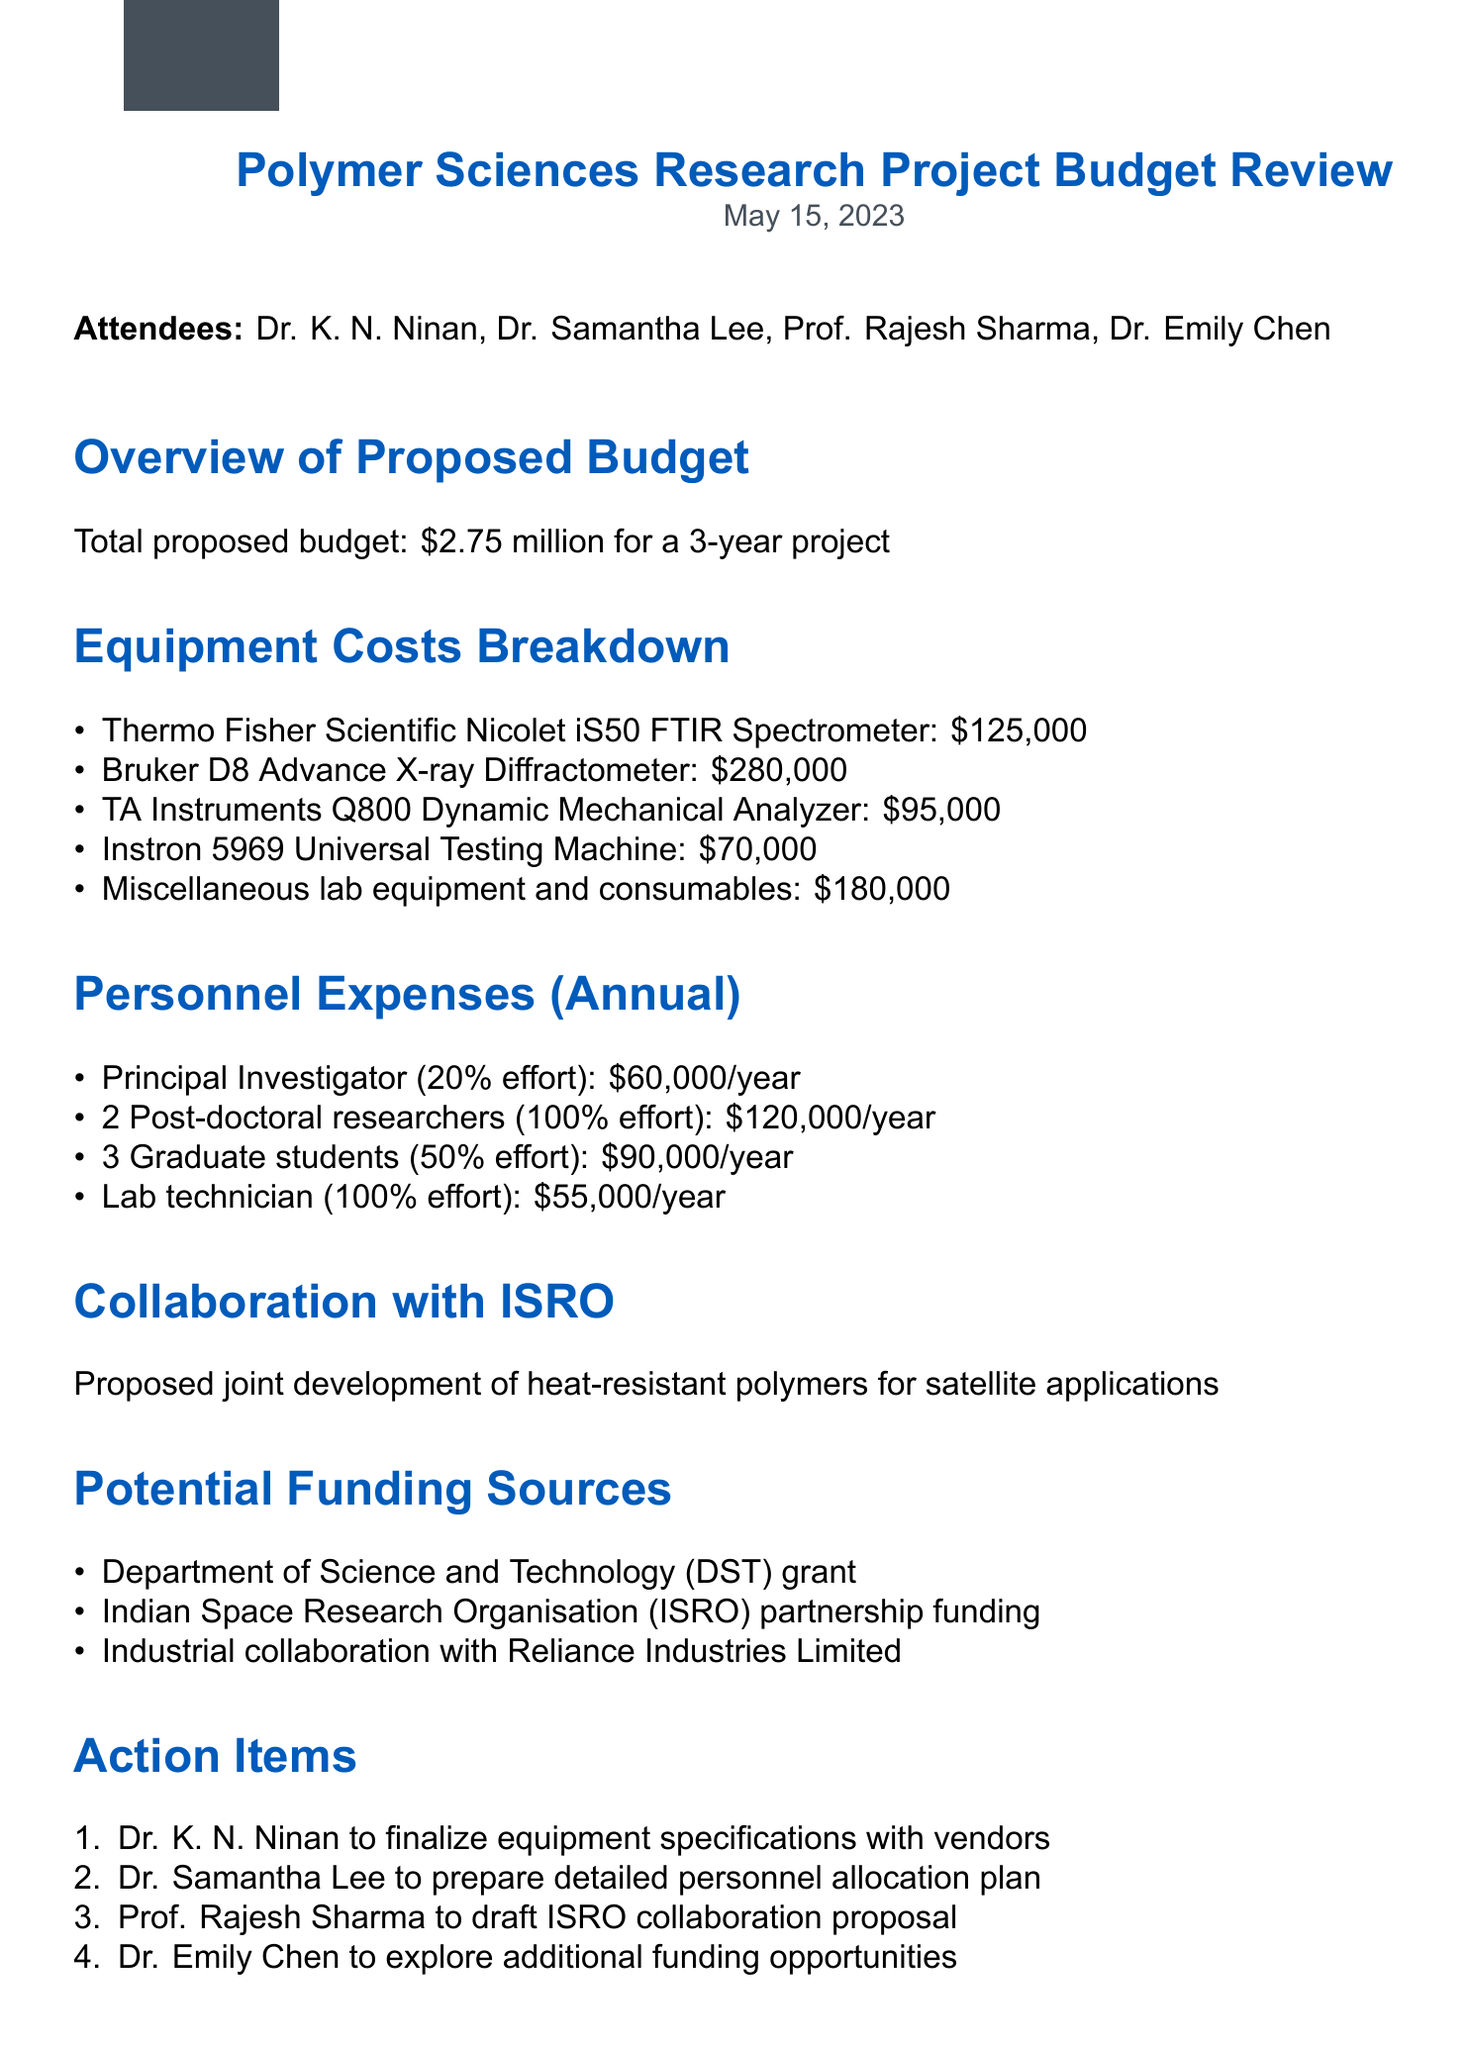what is the total proposed budget? The total proposed budget for the project is summarized in the document as a single amount.
Answer: $2.75 million who is the Principal Investigator? The meeting minutes mention all attendees including the Principal Investigator role.
Answer: Dr. K. N. Ninan how many graduate students are allocated in the budget? This question refers to the personnel expenses section of the budget that specifies the number of graduate students.
Answer: 3 what is the cost of the Bruker D8 Advance X-ray Diffractometer? This price detail is included in the equipment costs breakdown for clear financial planning.
Answer: $280,000 which organization is proposed for collaboration on this project? The document discusses collaboration for the project and names the organization involved.
Answer: ISRO how much does a lab technician cost annually? This figure is specified in the personnel expenses section to aid in budgeting decisions.
Answer: $55,000/year what percentage of effort does the Principal Investigator have? This is detailed in the personnel expenses section to clarify the commitment level of the Principal Investigator.
Answer: 20% who will prepare the detailed personnel allocation plan? This action item relates to the specific responsibility assigned during the meeting.
Answer: Dr. Samantha Lee what types of funding sources are mentioned? The document lists potential funding sources which are critical for financial planning.
Answer: DST grant, ISRO partnership funding, Reliance Industries Limited 